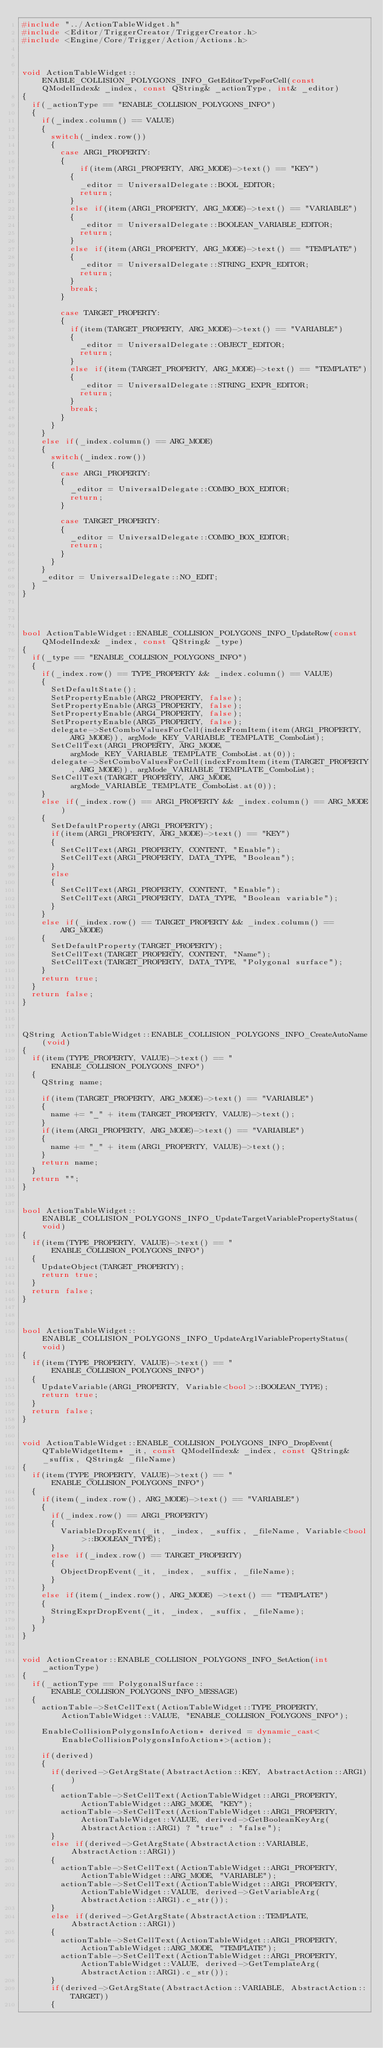<code> <loc_0><loc_0><loc_500><loc_500><_C++_>#include "../ActionTableWidget.h"
#include <Editor/TriggerCreator/TriggerCreator.h>
#include <Engine/Core/Trigger/Action/Actions.h>



void ActionTableWidget::ENABLE_COLLISION_POLYGONS_INFO_GetEditorTypeForCell(const QModelIndex& _index, const QString& _actionType, int& _editor)
{
	if(_actionType == "ENABLE_COLLISION_POLYGONS_INFO")
	{
		if(_index.column() == VALUE)
		{
			switch(_index.row())
			{
				case ARG1_PROPERTY:
				{
				    if(item(ARG1_PROPERTY, ARG_MODE)->text() == "KEY")
					{
						_editor = UniversalDelegate::BOOL_EDITOR;
						return;
					}
					else if(item(ARG1_PROPERTY, ARG_MODE)->text() == "VARIABLE")
					{
						_editor = UniversalDelegate::BOOLEAN_VARIABLE_EDITOR;
						return;
					}
					else if(item(ARG1_PROPERTY, ARG_MODE)->text() == "TEMPLATE")
					{
						_editor = UniversalDelegate::STRING_EXPR_EDITOR;
						return;
					}
					break;
				}
				
				case TARGET_PROPERTY:
				{
					if(item(TARGET_PROPERTY, ARG_MODE)->text() == "VARIABLE")
					{
						_editor = UniversalDelegate::OBJECT_EDITOR;
						return;
					}
					else if(item(TARGET_PROPERTY, ARG_MODE)->text() == "TEMPLATE")
					{
						_editor = UniversalDelegate::STRING_EXPR_EDITOR;
						return;
					}
					break;
				}
			}
		}
		else if(_index.column() == ARG_MODE)
		{
			switch(_index.row())
			{
				case ARG1_PROPERTY:
				{
					_editor = UniversalDelegate::COMBO_BOX_EDITOR;
					return;
				}

				case TARGET_PROPERTY:
				{
					_editor = UniversalDelegate::COMBO_BOX_EDITOR;
					return;
				}
			}
		}
		_editor = UniversalDelegate::NO_EDIT;
	}
}




bool ActionTableWidget::ENABLE_COLLISION_POLYGONS_INFO_UpdateRow(const QModelIndex& _index, const QString& _type)
{
	if(_type == "ENABLE_COLLISION_POLYGONS_INFO") 
	{
		if(_index.row() == TYPE_PROPERTY && _index.column() == VALUE)
		{
			SetDefaultState();
			SetPropertyEnable(ARG2_PROPERTY, false);
			SetPropertyEnable(ARG3_PROPERTY, false);
			SetPropertyEnable(ARG4_PROPERTY, false);
			SetPropertyEnable(ARG5_PROPERTY, false);
			delegate->SetComboValuesForCell(indexFromItem(item(ARG1_PROPERTY, ARG_MODE)), argMode_KEY_VARIABLE_TEMPLATE_ComboList);
			SetCellText(ARG1_PROPERTY, ARG_MODE, argMode_KEY_VARIABLE_TEMPLATE_ComboList.at(0));
			delegate->SetComboValuesForCell(indexFromItem(item(TARGET_PROPERTY, ARG_MODE)), argMode_VARIABLE_TEMPLATE_ComboList);
			SetCellText(TARGET_PROPERTY, ARG_MODE, argMode_VARIABLE_TEMPLATE_ComboList.at(0));
		}
		else if(_index.row() == ARG1_PROPERTY && _index.column() == ARG_MODE)
		{ 
			SetDefaultProperty(ARG1_PROPERTY);
			if(item(ARG1_PROPERTY, ARG_MODE)->text() == "KEY")
			{
				SetCellText(ARG1_PROPERTY, CONTENT, "Enable"); 
				SetCellText(ARG1_PROPERTY, DATA_TYPE, "Boolean");
			}
			else
			{
				SetCellText(ARG1_PROPERTY, CONTENT, "Enable"); 
				SetCellText(ARG1_PROPERTY, DATA_TYPE, "Boolean variable"); 
			}
		}
		else if(_index.row() == TARGET_PROPERTY && _index.column() == ARG_MODE)
		{
			SetDefaultProperty(TARGET_PROPERTY);
			SetCellText(TARGET_PROPERTY, CONTENT, "Name");
			SetCellText(TARGET_PROPERTY, DATA_TYPE, "Polygonal surface"); 
		}
		return true;
	}  
	return false;
}



QString ActionTableWidget::ENABLE_COLLISION_POLYGONS_INFO_CreateAutoName(void)
{
	if(item(TYPE_PROPERTY, VALUE)->text() == "ENABLE_COLLISION_POLYGONS_INFO")
	{ 
		QString name;

		if(item(TARGET_PROPERTY, ARG_MODE)->text() == "VARIABLE")
		{
			name += "_" + item(TARGET_PROPERTY, VALUE)->text(); 
		}
		if(item(ARG1_PROPERTY, ARG_MODE)->text() == "VARIABLE")
		{
			name += "_" + item(ARG1_PROPERTY, VALUE)->text();
		}
		return name;
	}
	return "";
}


bool ActionTableWidget::ENABLE_COLLISION_POLYGONS_INFO_UpdateTargetVariablePropertyStatus(void)
{
	if(item(TYPE_PROPERTY, VALUE)->text() == "ENABLE_COLLISION_POLYGONS_INFO")
	{ 
		UpdateObject(TARGET_PROPERTY);
		return true;
	}
	return false;
}



bool ActionTableWidget::ENABLE_COLLISION_POLYGONS_INFO_UpdateArg1VariablePropertyStatus(void)
{
	if(item(TYPE_PROPERTY, VALUE)->text() == "ENABLE_COLLISION_POLYGONS_INFO")
	{
		UpdateVariable(ARG1_PROPERTY, Variable<bool>::BOOLEAN_TYPE);
		return true;
	}
	return false;
}


void ActionTableWidget::ENABLE_COLLISION_POLYGONS_INFO_DropEvent(QTableWidgetItem* _it, const QModelIndex& _index, const QString& _suffix, QString& _fileName)
{
	if(item(TYPE_PROPERTY, VALUE)->text() == "ENABLE_COLLISION_POLYGONS_INFO")
	{
		if(item(_index.row(), ARG_MODE)->text() == "VARIABLE")
		{
			if(_index.row() == ARG1_PROPERTY)
			{
				VariableDropEvent(_it, _index, _suffix, _fileName, Variable<bool>::BOOLEAN_TYPE);
			}
			else if(_index.row() == TARGET_PROPERTY)
			{
				ObjectDropEvent(_it, _index, _suffix, _fileName);
			}
		}
		else if(item(_index.row(), ARG_MODE) ->text() == "TEMPLATE")
		{ 
			StringExprDropEvent(_it, _index, _suffix, _fileName);
		}
	}
}


void ActionCreator::ENABLE_COLLISION_POLYGONS_INFO_SetAction(int _actionType)
{
	if(_actionType == PolygonalSurface::ENABLE_COLLISION_POLYGONS_INFO_MESSAGE)
	{
		actionTable->SetCellText(ActionTableWidget::TYPE_PROPERTY, ActionTableWidget::VALUE, "ENABLE_COLLISION_POLYGONS_INFO");

		EnableCollisionPolygonsInfoAction* derived = dynamic_cast<EnableCollisionPolygonsInfoAction*>(action);
		
		if(derived)
		{
			if(derived->GetArgState(AbstractAction::KEY, AbstractAction::ARG1))
			{
				actionTable->SetCellText(ActionTableWidget::ARG1_PROPERTY, ActionTableWidget::ARG_MODE, "KEY");
				actionTable->SetCellText(ActionTableWidget::ARG1_PROPERTY, ActionTableWidget::VALUE, derived->GetBooleanKeyArg(AbstractAction::ARG1) ? "true" : "false");
			}
			else if(derived->GetArgState(AbstractAction::VARIABLE, AbstractAction::ARG1))
			{
				actionTable->SetCellText(ActionTableWidget::ARG1_PROPERTY, ActionTableWidget::ARG_MODE, "VARIABLE");
				actionTable->SetCellText(ActionTableWidget::ARG1_PROPERTY, ActionTableWidget::VALUE, derived->GetVariableArg(AbstractAction::ARG1).c_str());
			}
			else if(derived->GetArgState(AbstractAction::TEMPLATE, AbstractAction::ARG1))
			{
				actionTable->SetCellText(ActionTableWidget::ARG1_PROPERTY, ActionTableWidget::ARG_MODE, "TEMPLATE");
				actionTable->SetCellText(ActionTableWidget::ARG1_PROPERTY, ActionTableWidget::VALUE, derived->GetTemplateArg(AbstractAction::ARG1).c_str());
			}
			if(derived->GetArgState(AbstractAction::VARIABLE, AbstractAction::TARGET))
			{</code> 